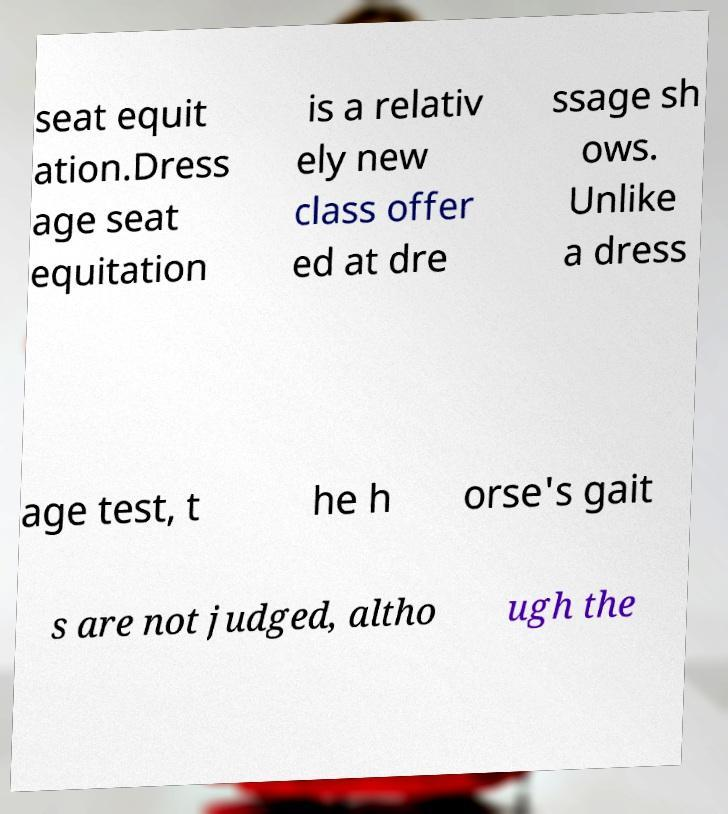There's text embedded in this image that I need extracted. Can you transcribe it verbatim? seat equit ation.Dress age seat equitation is a relativ ely new class offer ed at dre ssage sh ows. Unlike a dress age test, t he h orse's gait s are not judged, altho ugh the 